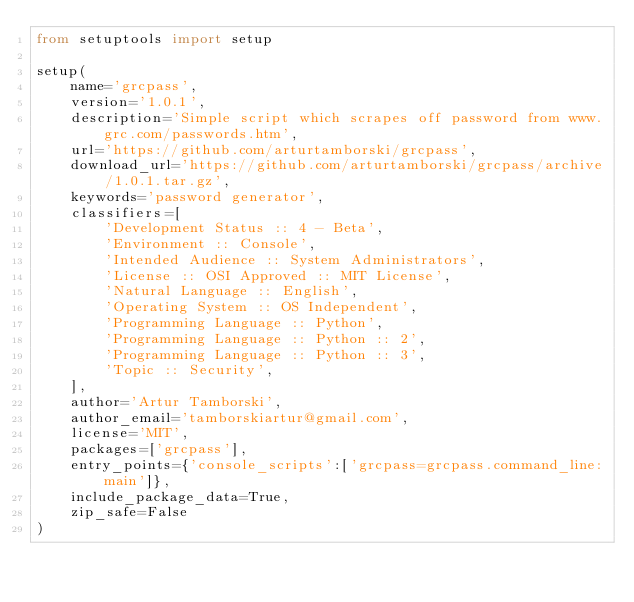<code> <loc_0><loc_0><loc_500><loc_500><_Python_>from setuptools import setup

setup(
    name='grcpass',
    version='1.0.1',
    description='Simple script which scrapes off password from www.grc.com/passwords.htm',
    url='https://github.com/arturtamborski/grcpass',
    download_url='https://github.com/arturtamborski/grcpass/archive/1.0.1.tar.gz',
    keywords='password generator',
    classifiers=[
        'Development Status :: 4 - Beta',
        'Environment :: Console',
        'Intended Audience :: System Administrators',
        'License :: OSI Approved :: MIT License',
        'Natural Language :: English',
        'Operating System :: OS Independent',
        'Programming Language :: Python',
        'Programming Language :: Python :: 2',
        'Programming Language :: Python :: 3',
        'Topic :: Security',
    ],
    author='Artur Tamborski',
    author_email='tamborskiartur@gmail.com',
    license='MIT',
    packages=['grcpass'],
    entry_points={'console_scripts':['grcpass=grcpass.command_line:main']},
    include_package_data=True,
    zip_safe=False
)
</code> 